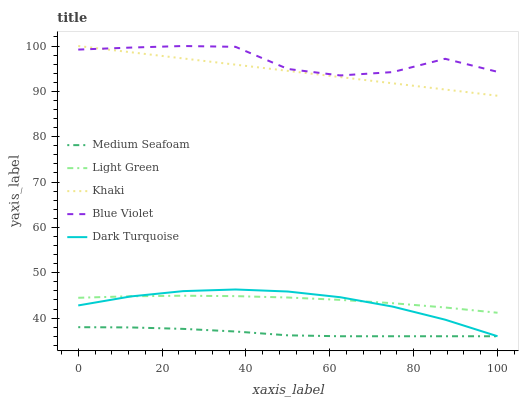Does Medium Seafoam have the minimum area under the curve?
Answer yes or no. Yes. Does Blue Violet have the maximum area under the curve?
Answer yes or no. Yes. Does Dark Turquoise have the minimum area under the curve?
Answer yes or no. No. Does Dark Turquoise have the maximum area under the curve?
Answer yes or no. No. Is Khaki the smoothest?
Answer yes or no. Yes. Is Blue Violet the roughest?
Answer yes or no. Yes. Is Dark Turquoise the smoothest?
Answer yes or no. No. Is Dark Turquoise the roughest?
Answer yes or no. No. Does Dark Turquoise have the lowest value?
Answer yes or no. Yes. Does Khaki have the lowest value?
Answer yes or no. No. Does Khaki have the highest value?
Answer yes or no. Yes. Does Dark Turquoise have the highest value?
Answer yes or no. No. Is Light Green less than Khaki?
Answer yes or no. Yes. Is Khaki greater than Medium Seafoam?
Answer yes or no. Yes. Does Light Green intersect Dark Turquoise?
Answer yes or no. Yes. Is Light Green less than Dark Turquoise?
Answer yes or no. No. Is Light Green greater than Dark Turquoise?
Answer yes or no. No. Does Light Green intersect Khaki?
Answer yes or no. No. 